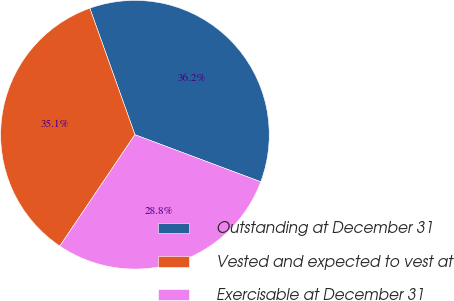Convert chart. <chart><loc_0><loc_0><loc_500><loc_500><pie_chart><fcel>Outstanding at December 31<fcel>Vested and expected to vest at<fcel>Exercisable at December 31<nl><fcel>36.15%<fcel>35.1%<fcel>28.75%<nl></chart> 